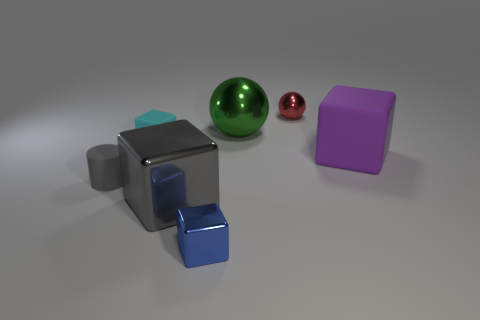Is the color of the small matte cylinder the same as the metal cube that is to the left of the small blue cube?
Your response must be concise. Yes. Is there anything else that is the same color as the tiny cylinder?
Provide a short and direct response. Yes. There is a small matte thing that is the same color as the large shiny cube; what is its shape?
Provide a succinct answer. Cylinder. Is the size of the purple thing the same as the gray metal object?
Offer a terse response. Yes. Are there more shiny balls that are on the left side of the tiny red metallic ball than small gray spheres?
Your response must be concise. Yes. What is the size of the gray cube that is made of the same material as the large green ball?
Give a very brief answer. Large. There is a gray matte cylinder; are there any small things behind it?
Your answer should be very brief. Yes. Is the shape of the large matte thing the same as the small cyan rubber object?
Provide a short and direct response. Yes. There is a gray object that is to the left of the tiny block on the left side of the tiny shiny thing in front of the tiny cylinder; what is its size?
Keep it short and to the point. Small. What is the purple cube made of?
Your answer should be compact. Rubber. 